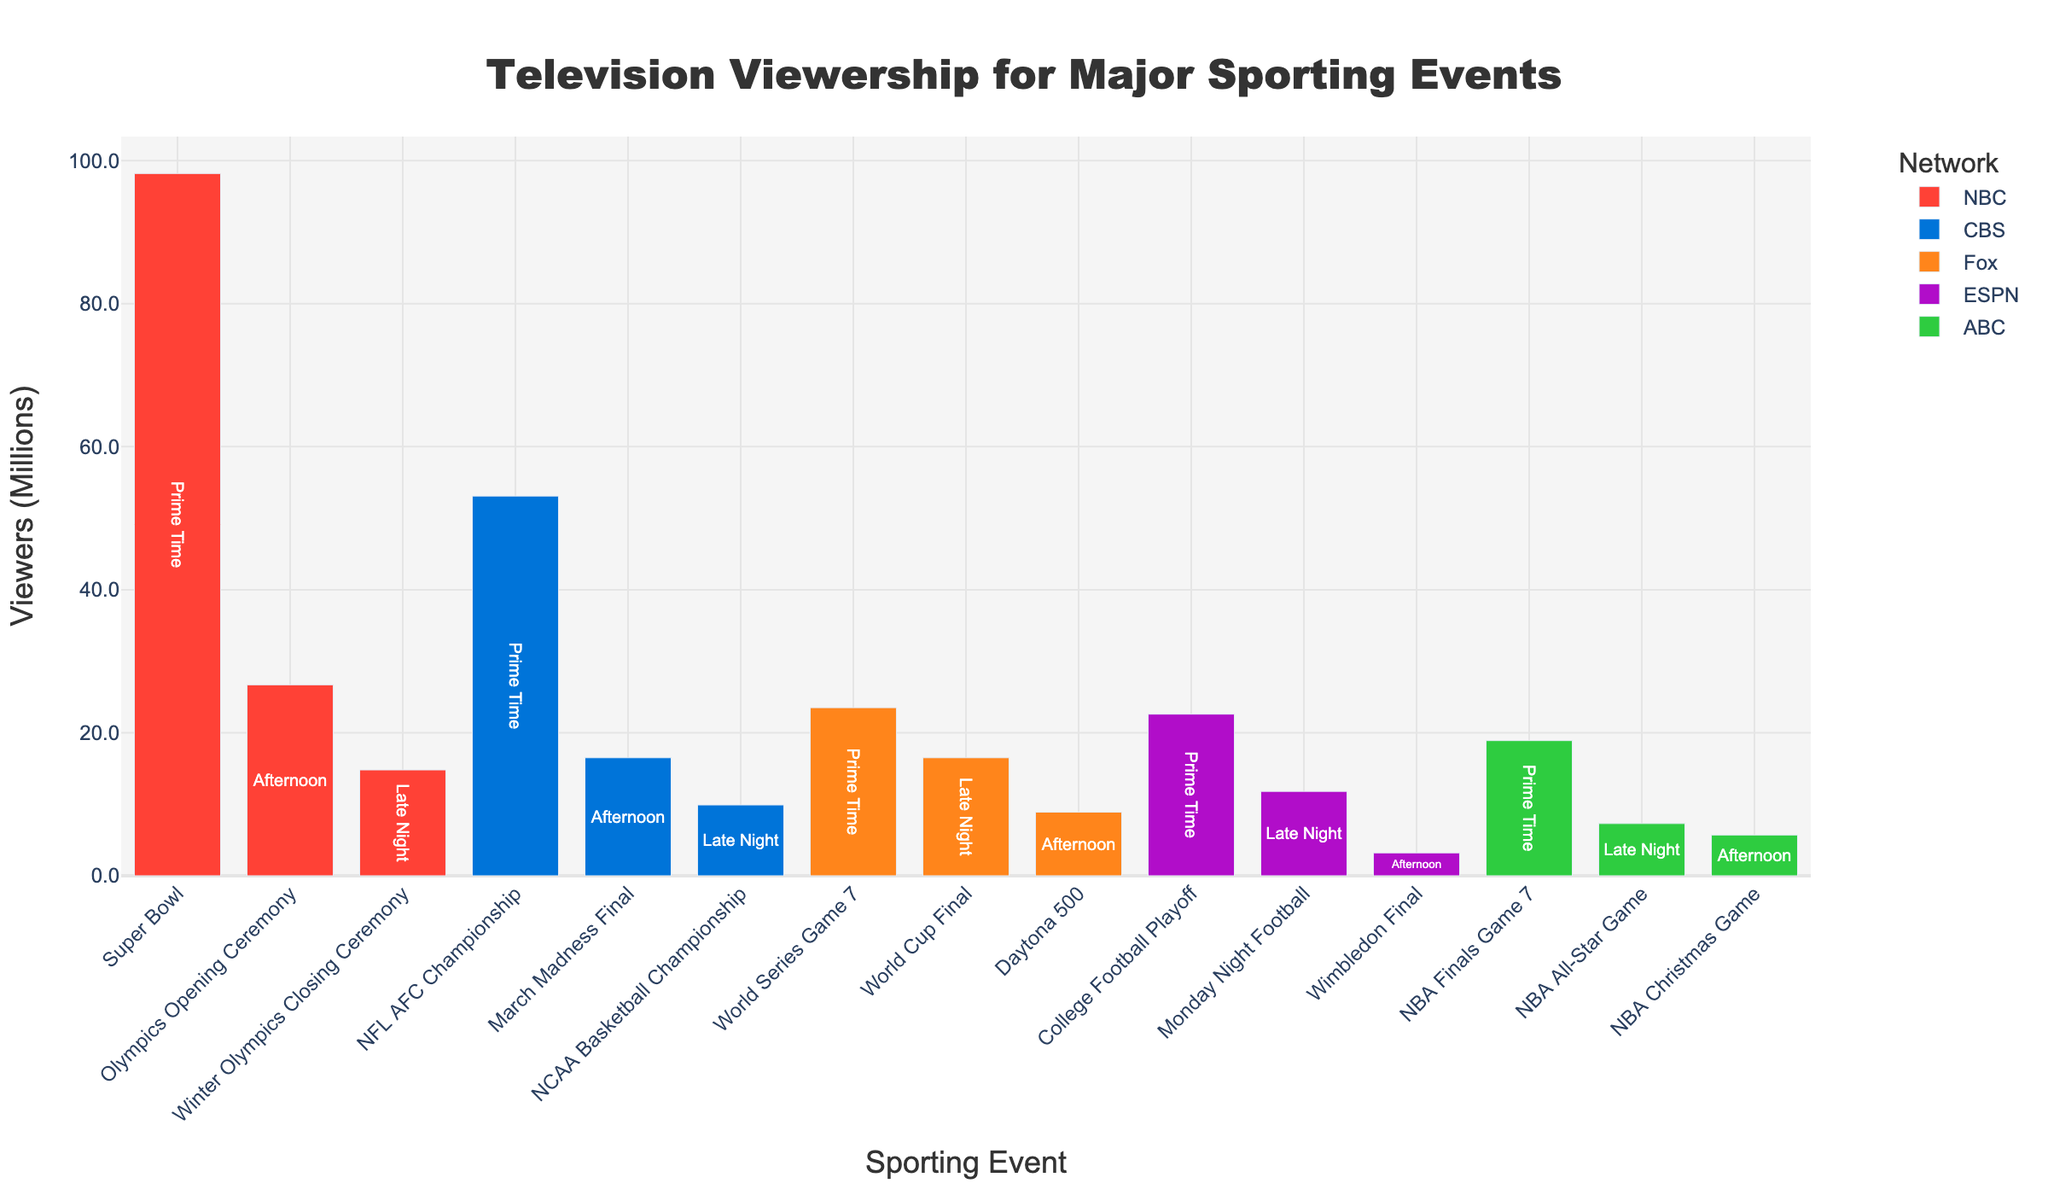How many sporting events are displayed for NBC? First, look at the unique sporting events (bars) for NBC in the graph. NBC has the following events: Super Bowl, Olympics Opening Ceremony, and Winter Olympics Closing Ceremony. Count these events.
Answer: 3 What is the title of the figure? Look at the top of the figure where the title is displayed.
Answer: Television Viewership for Major Sporting Events Which event has the highest number of viewers, and how many? Look at the y-axis for the highest bar and its corresponding x-axis event. Additionally, check the number displayed on the bar representing the viewers in millions. The highest bar is for the Super Bowl.
Answer: Super Bowl, 98.2 million Which network has the least number of viewers, and for which event? Identify the lowest bar across all networks and look at the x-axis to determine the event and the bar's color to determine the network. The lowest bar is for ESPN (Wimbledon Final).
Answer: ESPN, Wimbledon Final How many events took place during the Afternoon time slot? Check and count the bars marked with "Afternoon" inside the bars. These are Olympics Opening Ceremony, March Madness Final, Daytona 500, NBA Christmas Game, and Wimbledon Final.
Answer: 5 What is the combined viewership of the NFL AFC Championship, World Series Game 7, and NBA Finals Game 7? Sum the viewers (in millions) for these three events. NFL AFC Championship has 53.1 million, World Series Game 7 has 23.5 million, and NBA Finals Game 7 has 18.9 million. 53.1 + 23.5 + 18.9 = 95.5 million.
Answer: 95.5 million Which network has the most events in the Late Night time slot? Count the Late Night events for each network. NBC (only has the Winter Olympics Closing Ceremony), CBS (NCAA Basketball Championship), Fox (World Cup Final), ABC (NBA All-Star Game), ESPN (Monday Night Football). All have one event.
Answer: Equal for all networks with Late Night events What is the viewership difference between the event with the most viewers and the event with the least viewers? Identify the highest and lowest viewers (in millions) from the bars. The highest is 98.2 million for the Super Bowl, and the lowest is 3.2 million for Wimbledon Final. The difference is 98.2 - 3.2.
Answer: 95 million Which network has the highest cumulative viewership across all events? Sum the viewers for each network: NBC (98.2 + 26.7 + 14.8) = 139.7 million, CBS (53.1 + 16.5 + 9.9) = 79.5 million, Fox (23.5 + 8.9 + 16.5) = 48.9 million, ABC (18.9 + 5.7 + 7.3) = 31.9 million, ESPN (22.6 + 3.2 + 11.8) = 37.6 million. Compare sums.
Answer: NBC What is the average viewership for the events broadcast by ABC? Sum the viewership for ABC's events (18.9 million, 5.7 million, 7.3 million) and divide by the number of events. (18.9 + 5.7 + 7.3) / 3 = 31.9 / 3
Answer: 10.63 million 